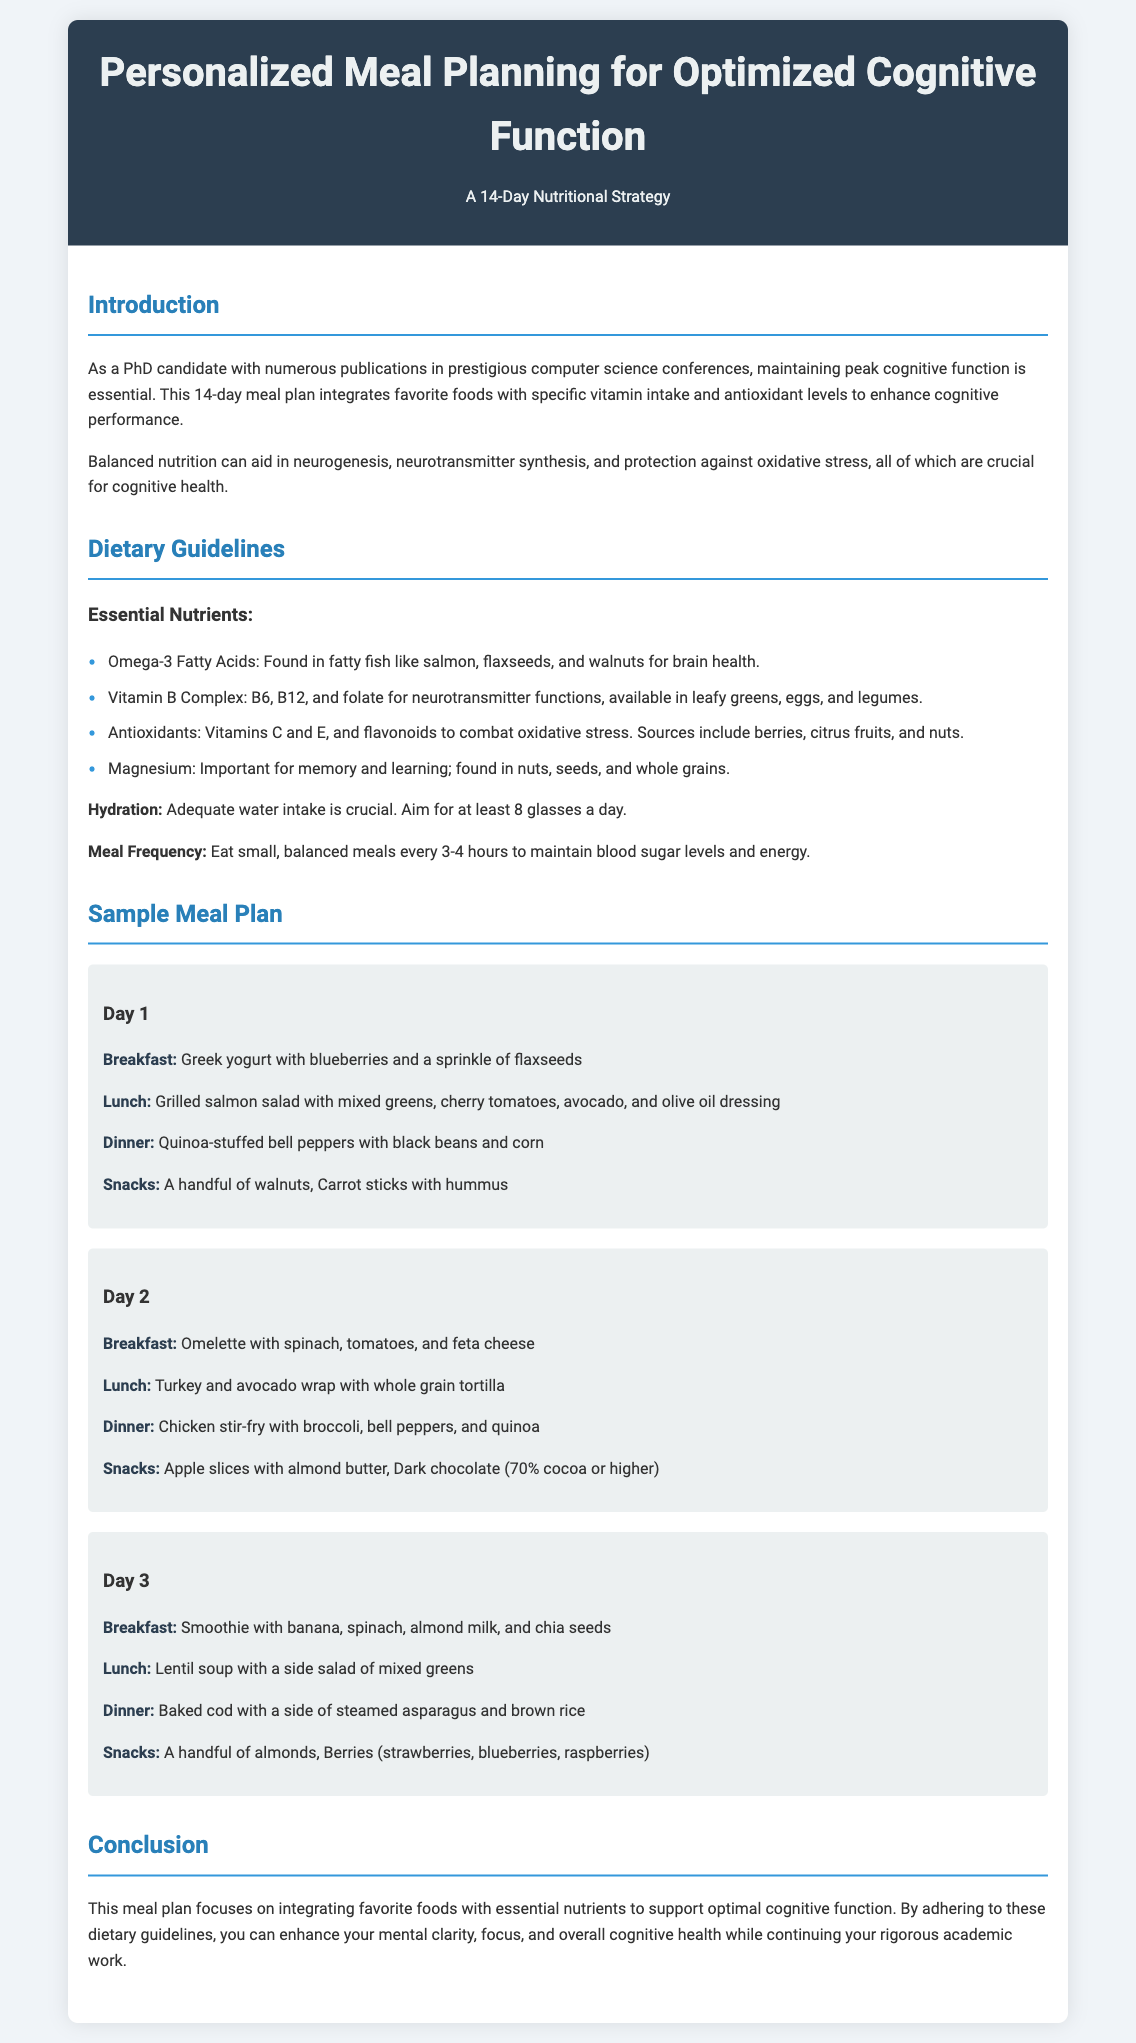What is the title of the meal plan? The title of the meal plan is prominently displayed at the top of the document.
Answer: Personalized Meal Planning for Optimized Cognitive Function How many days does the meal plan cover? The text clearly states the duration of the meal plan in the introduction section.
Answer: 14 days What are essential nutrients mentioned in the dietary guidelines? The dietary guidelines list specific nutrients important for cognitive function.
Answer: Omega-3 Fatty Acids, Vitamin B Complex, Antioxidants, Magnesium What is the first snack listed in Day 1? The snacks for Day 1 are specified in the meal plan section under that day's details.
Answer: A handful of walnuts Which meal type is emphasized to help with cognitive health? The introduction section implies the importance of balanced meals for cognitive health.
Answer: Balanced meals On which day is the omelette with spinach served? The meal plan details what is served on each day, allowing for direct retrieval of this information.
Answer: Day 2 What food is included in the dinner for Day 3? Dinner options are explicitly outlined for each day in the meal plan.
Answer: Baked cod with a side of steamed asparagus and brown rice How often should meals be consumed according to the guidelines? The guidelines specify a meal frequency recommendation to optimize health.
Answer: Every 3-4 hours 